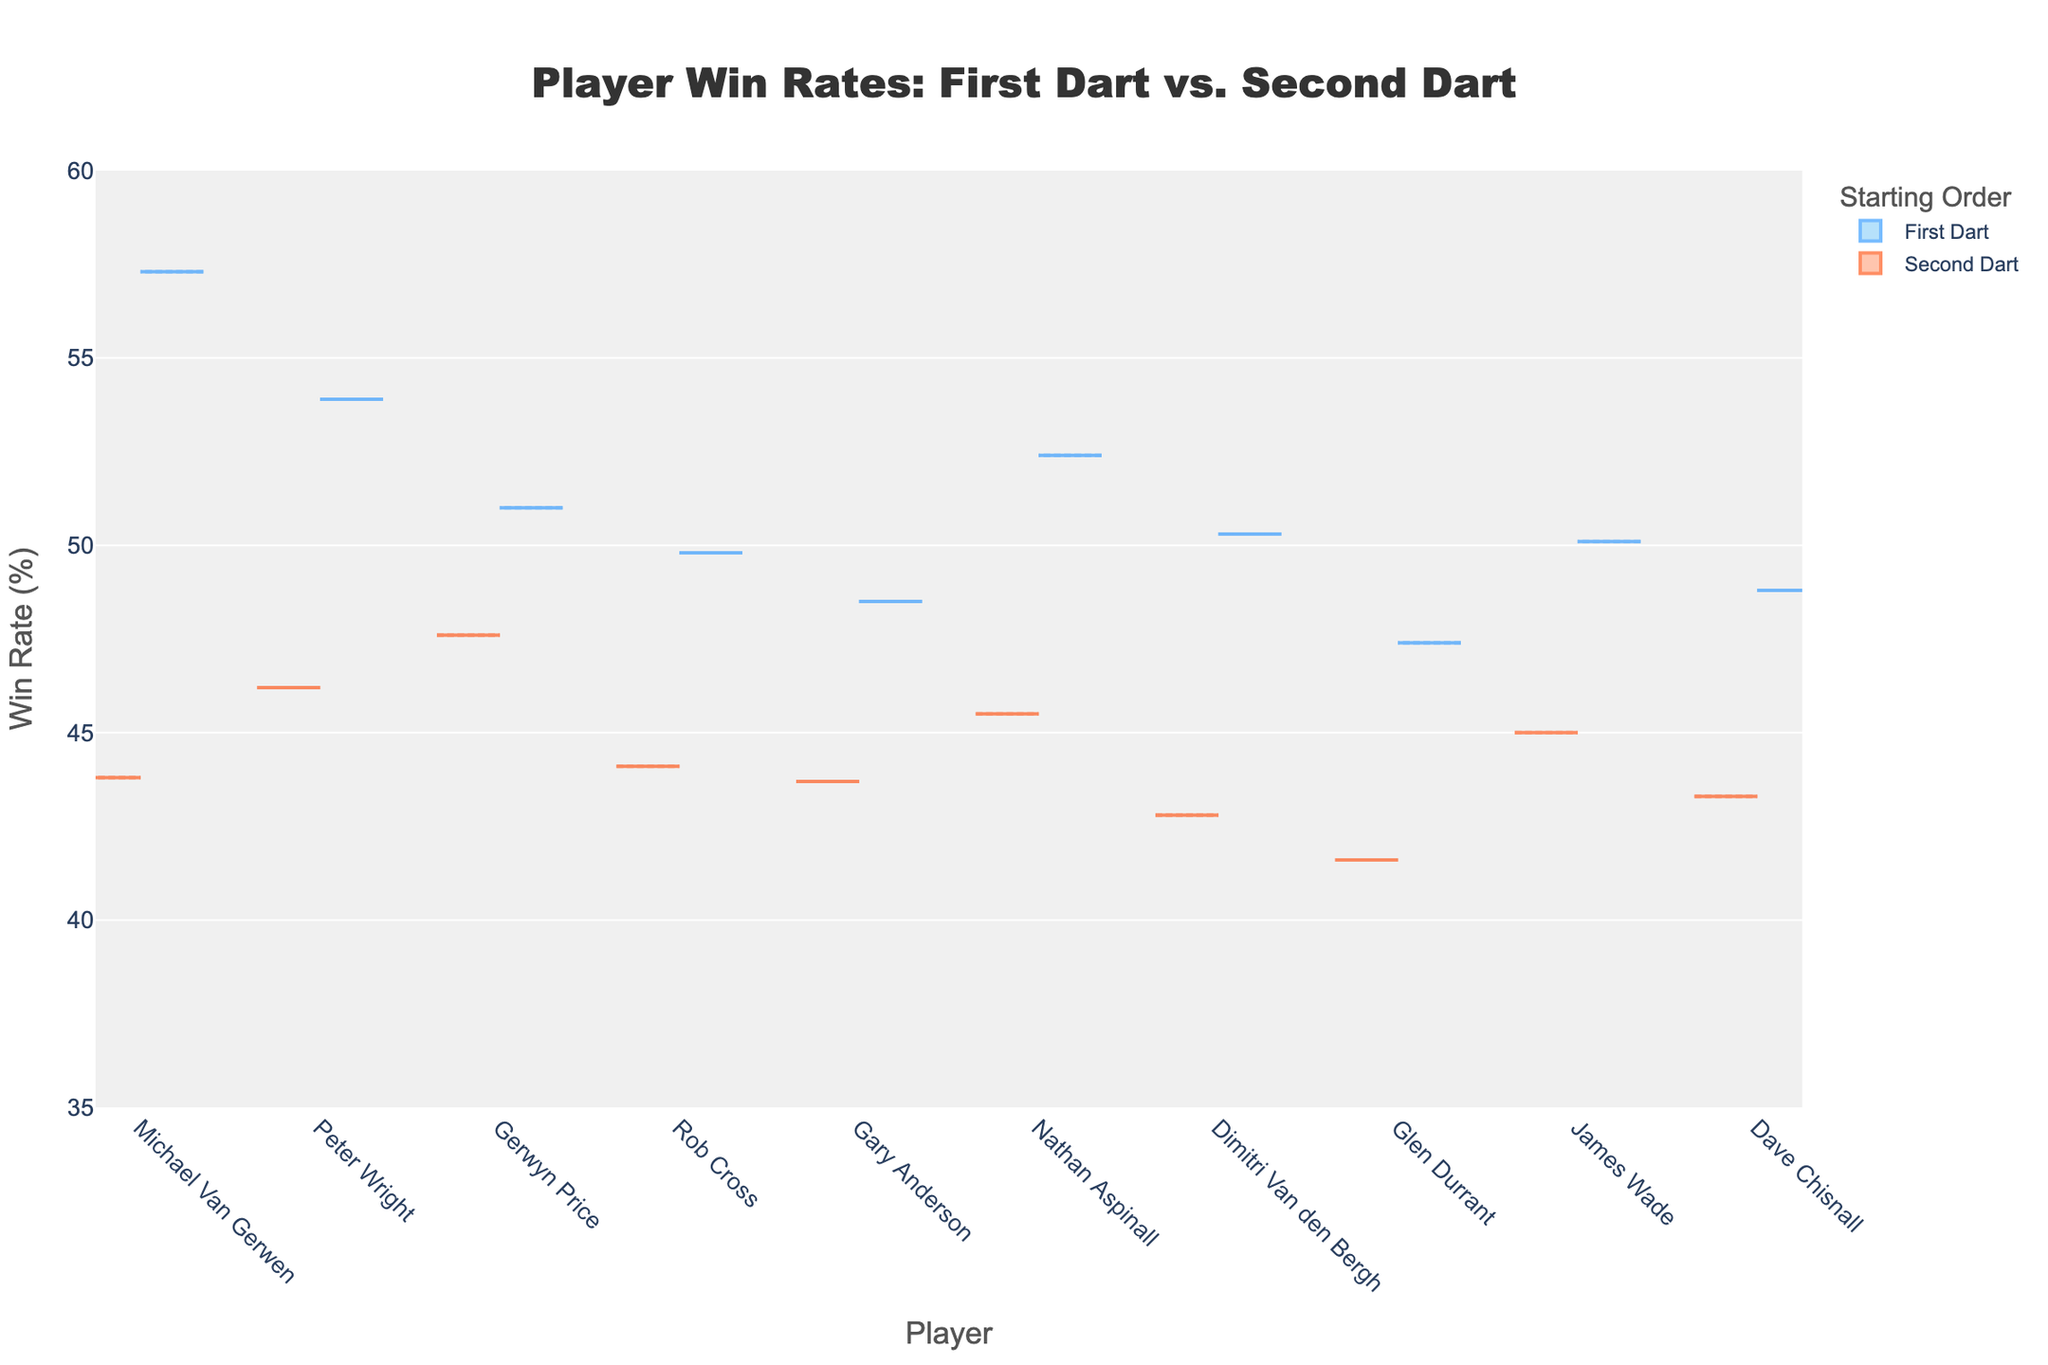What's the title of the plot? The title of the plot is usually at the top of the figure and gives an overview of what the chart represents. Here, the title is clearly stated at the top.
Answer: Player Win Rates: First Dart vs. Second Dart What's the win rate for Michael Van Gerwen when he starts first? To find Michael Van Gerwen's win rate when he starts first, look for his name on the x-axis and refer to the first dart (usually positive) side of the violin plot.
Answer: 57.3% Does Peter Wright perform better starting first or second? Compare the win rates on the violin plot for Peter Wright for the first dart (positive side) and the second dart (negative side). The win rate is higher for the first dart.
Answer: First Who has the lowest win rate when starting second? Look at the negative side of the violin plot for each player and identify the lowest point. Dimitri Van den Bergh has the lowest win rate when starting second.
Answer: Dimitri Van den Bergh What's the average win rate for all players when they start first? Sum all win rates for players starting first and divide by the total number of players. (57.3 + 53.9 + 51.0 + 49.8 + 48.5 + 52.4 + 50.3 + 47.4 + 50.1 + 48.8) / 10 = 50.95
Answer: 50.95% Which player has the smallest difference in win rate between starting first and second? Calculate the difference in win rates between first and second darts for each player and find the smallest value. James Wade:
Answer: James Wade How does Gerwyn Price's win rate compare when starting first versus second? To compare, look at Gerwyn Price's position on the x-axis and check the win rates on both sides of the violin plot. The first dart win rate is higher.
Answer: Higher when starting first What's the range of win rates for all players when starting second? Identify the highest and lowest win rates when starting second from the negative side of the violin plot. The highest is Michael Van Gerwen (43.8%) and the lowest is Dimitri Van den Bergh (42.8%). Range is 43.8 - 42.8.
Answer: 42.8% - 43.8% Which player has the highest win rate regardless of starting order? Look at both sides of the violin plot and identify the highest single data point. Michael Van Gerwen has the highest win rate when starting first.
Answer: Michael Van Gerwen 